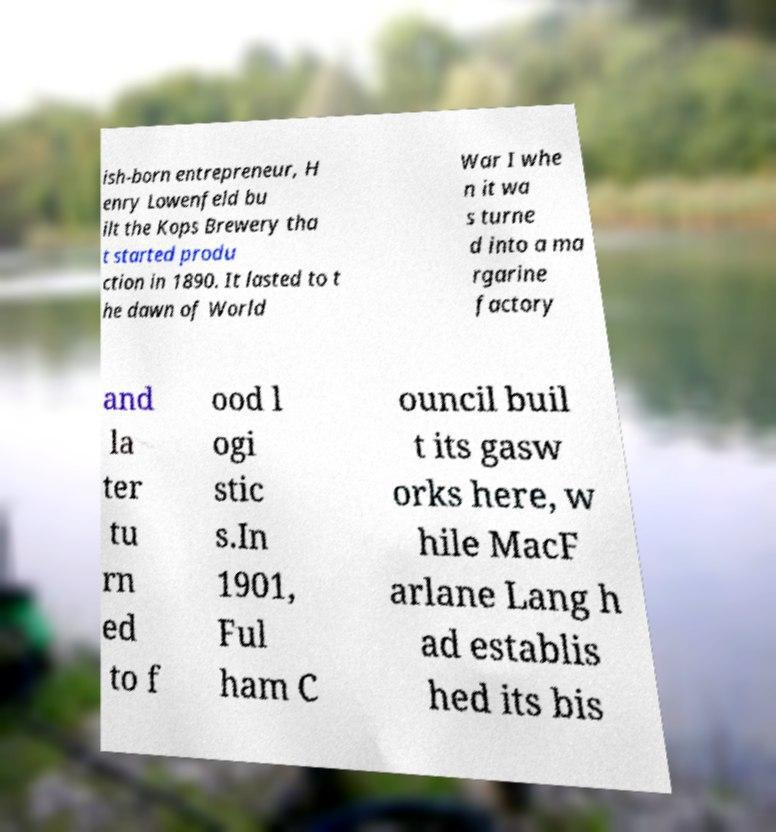Can you accurately transcribe the text from the provided image for me? ish-born entrepreneur, H enry Lowenfeld bu ilt the Kops Brewery tha t started produ ction in 1890. It lasted to t he dawn of World War I whe n it wa s turne d into a ma rgarine factory and la ter tu rn ed to f ood l ogi stic s.In 1901, Ful ham C ouncil buil t its gasw orks here, w hile MacF arlane Lang h ad establis hed its bis 